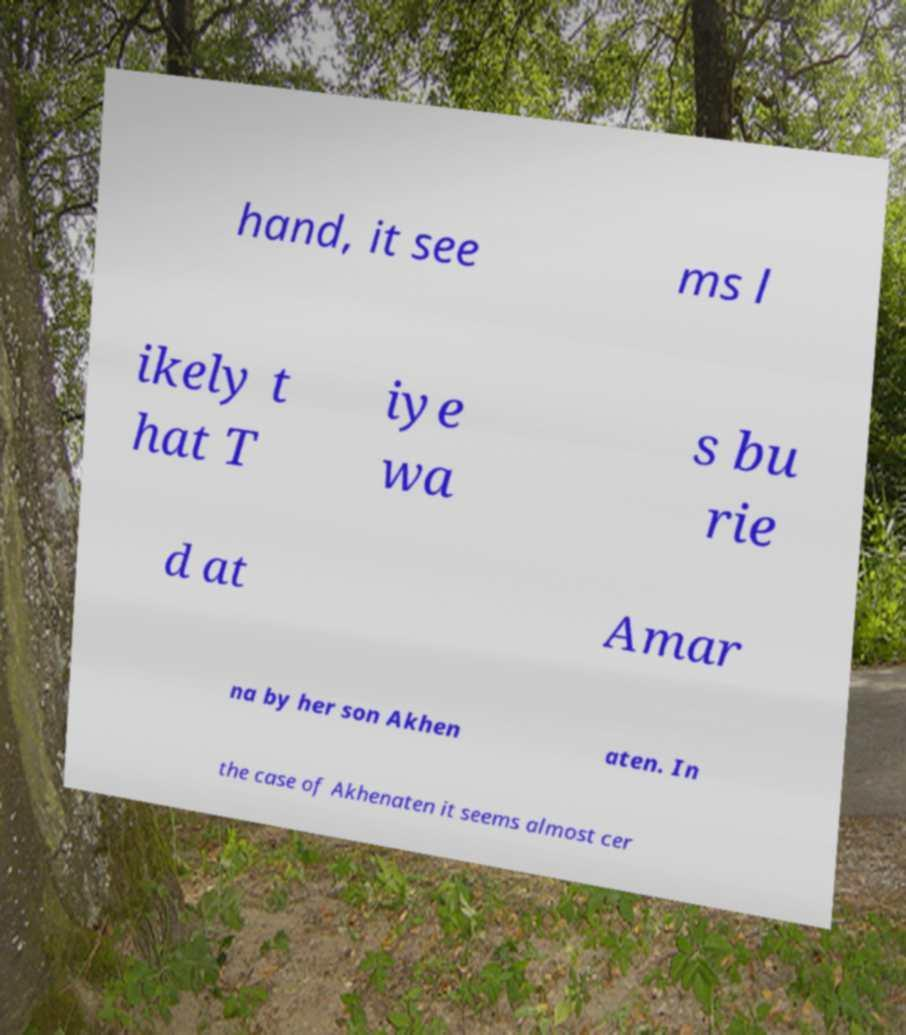Can you read and provide the text displayed in the image?This photo seems to have some interesting text. Can you extract and type it out for me? hand, it see ms l ikely t hat T iye wa s bu rie d at Amar na by her son Akhen aten. In the case of Akhenaten it seems almost cer 